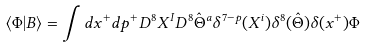Convert formula to latex. <formula><loc_0><loc_0><loc_500><loc_500>\langle \Phi | B \rangle = \int d x ^ { + } d p ^ { + } D ^ { 8 } X ^ { I } D ^ { 8 } \hat { \Theta } ^ { a } \delta ^ { 7 - p } ( X ^ { i } ) \delta ^ { 8 } ( \hat { \Theta } ) \delta ( x ^ { + } ) \Phi</formula> 